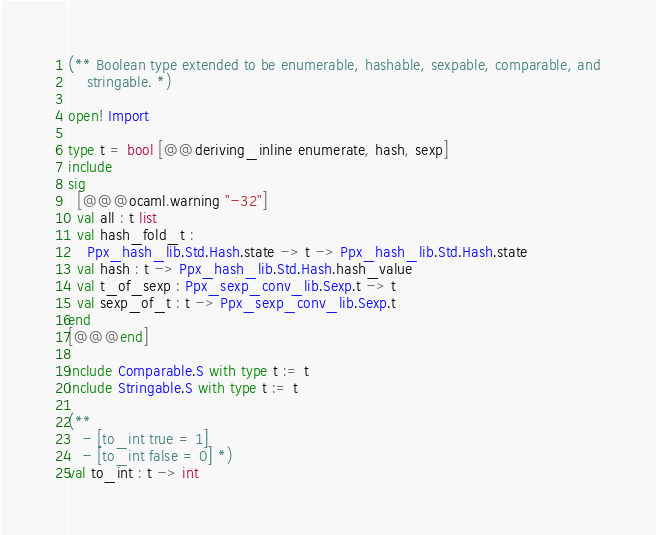Convert code to text. <code><loc_0><loc_0><loc_500><loc_500><_OCaml_>(** Boolean type extended to be enumerable, hashable, sexpable, comparable, and
    stringable. *)

open! Import

type t = bool [@@deriving_inline enumerate, hash, sexp]
include
sig
  [@@@ocaml.warning "-32"]
  val all : t list
  val hash_fold_t :
    Ppx_hash_lib.Std.Hash.state -> t -> Ppx_hash_lib.Std.Hash.state
  val hash : t -> Ppx_hash_lib.Std.Hash.hash_value
  val t_of_sexp : Ppx_sexp_conv_lib.Sexp.t -> t
  val sexp_of_t : t -> Ppx_sexp_conv_lib.Sexp.t
end
[@@@end]

include Comparable.S with type t := t
include Stringable.S with type t := t

(**
   - [to_int true = 1]
   - [to_int false = 0] *)
val to_int : t -> int
</code> 